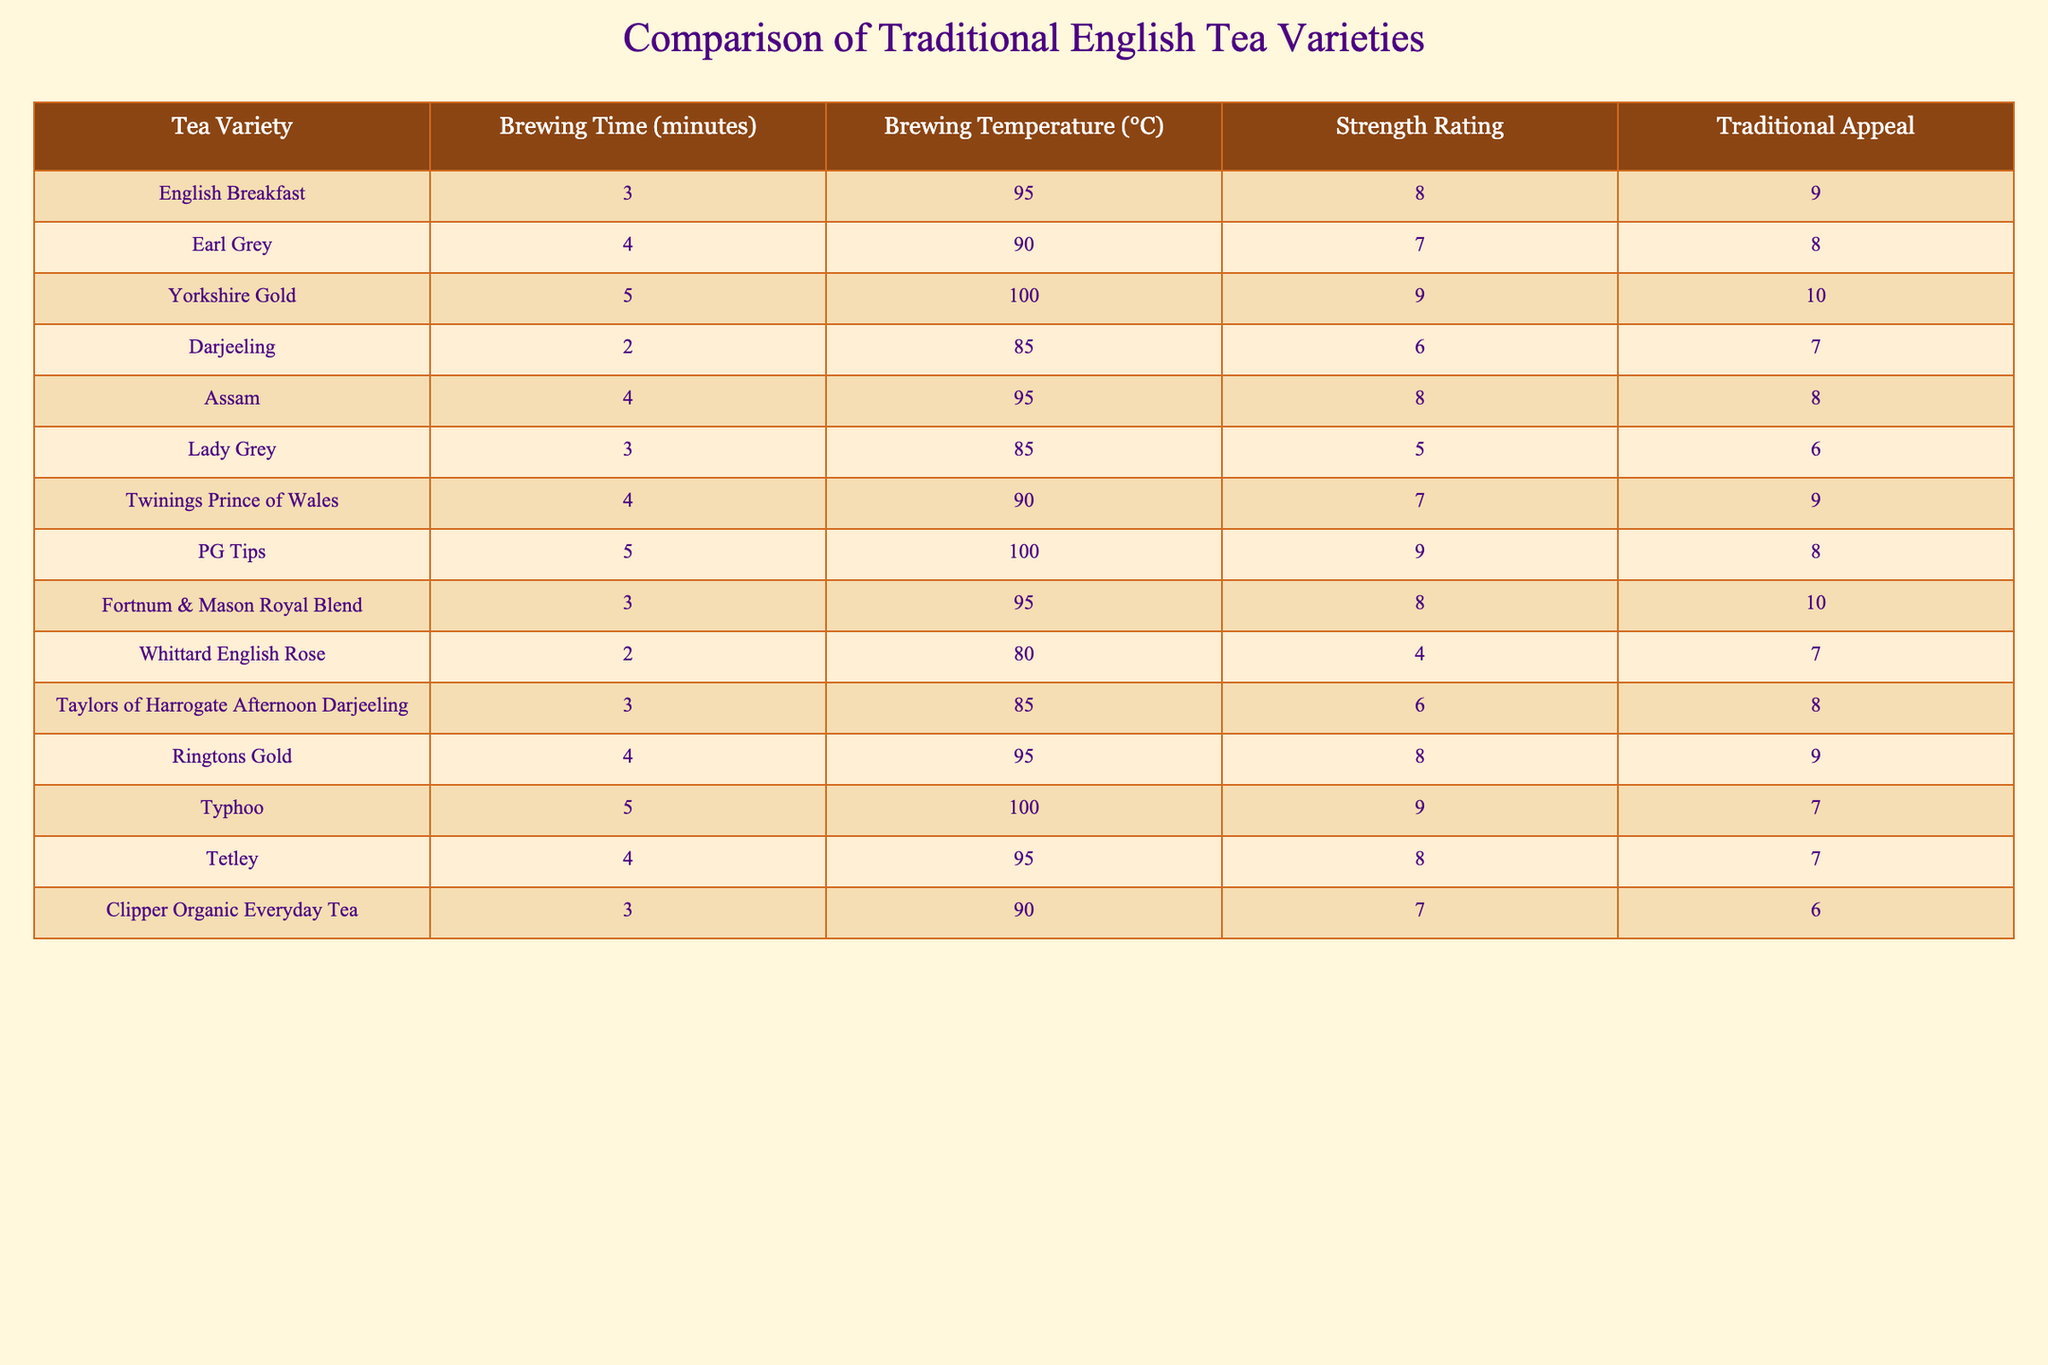What is the brewing temperature of Yorkshire Gold? The table lists Yorkshire Gold under the "Tea Variety" column, and the corresponding brewing temperature in the same row is shown in the "Brewing Temperature (°C)" column. The value is 100°C.
Answer: 100°C Which tea has the shortest brewing time? By examining the "Brewing Time (minutes)" column, it can be seen that both Darjeeling and Whittard English Rose have a brewing time of 2 minutes, which is the least compared to the others.
Answer: Darjeeling and Whittard English Rose What is the strength rating of Earl Grey? Earl Grey is listed in the table and the "Strength Rating" column next to it shows the value of 7.
Answer: 7 Which tea variety has the highest traditional appeal? Looking at the "Traditional Appeal" column, Yorkshire Gold has the highest score of 10, indicating it is considered most appealing traditionally.
Answer: Yorkshire Gold How many teas have a brewing temperature above 90°C? By counting the brewing temperatures in the table that exceed 90°C, the following teas qualify: English Breakfast, Yorkshire Gold, PG Tips, and Typhoo. There are a total of 4 teas.
Answer: 4 What is the average brewing time of all the tea varieties listed? To find the average, add up all the brewing times: 3 + 4 + 5 + 2 + 4 + 3 + 4 + 5 + 3 + 2 + 3 + 4 + 5 + 4 + 3 = 53 minutes. There are 15 varieties, so the average is 53/15 = approximately 3.53 minutes.
Answer: 3.53 minutes Is there any tea with a strength rating of 10? Checking the "Strength Rating" column reveals that Yorkshire Gold is the only tea variety that has a strength rating of 9; hence, there are no teas rated 10.
Answer: No Which tea varieties have a traditional appeal score less than 7? In the "Traditional Appeal" column, only Lady Grey (6) and Clipper Organic Everyday Tea (6) have scores lower than 7, totaling 2 tea varieties.
Answer: 2 varieties What is the difference in brewing time between English Breakfast and Assam? English Breakfast has a brewing time of 3 minutes while Assam has 4 minutes. The difference is calculated as 4 - 3 = 1 minute.
Answer: 1 minute List all teas with a strength rating of 8 or higher. From the "Strength Rating" column, the teas with ratings of 8 or higher are: English Breakfast (8), Assam (8), Yorkshire Gold (9), PG Tips (9), Ringtons Gold (8), and Typhoo (9). This gives us a total of 6 such teas.
Answer: 6 teas 